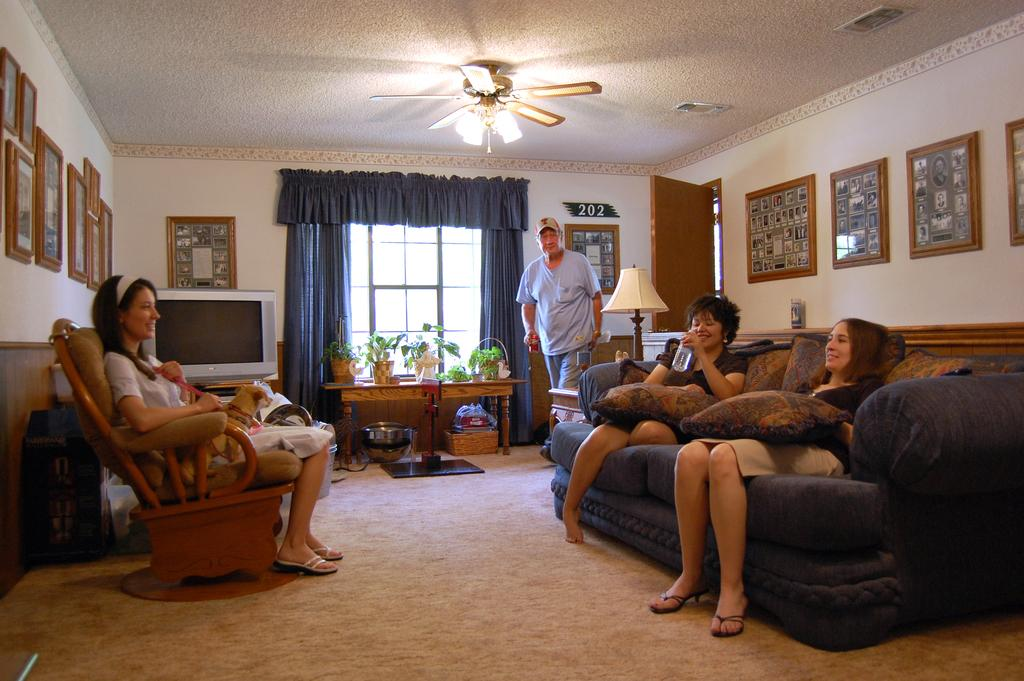What is the color of the wall in the image? The wall in the image is white. What objects can be seen on the wall? There are photo frames on the wall in the image. What device is present to provide air circulation? There is a fan in the image. What architectural feature is visible in the image? There is a window in the image, and it has a curtain associated with it. What piece of furniture is present in the image? There is a table in the image. What are the people in the image doing? There are people sitting on sofas in the image. What is the source of light in the image? There is a lamp in the image. What type of van can be seen in the image? There is no van present in the image. 